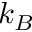<formula> <loc_0><loc_0><loc_500><loc_500>k _ { B }</formula> 